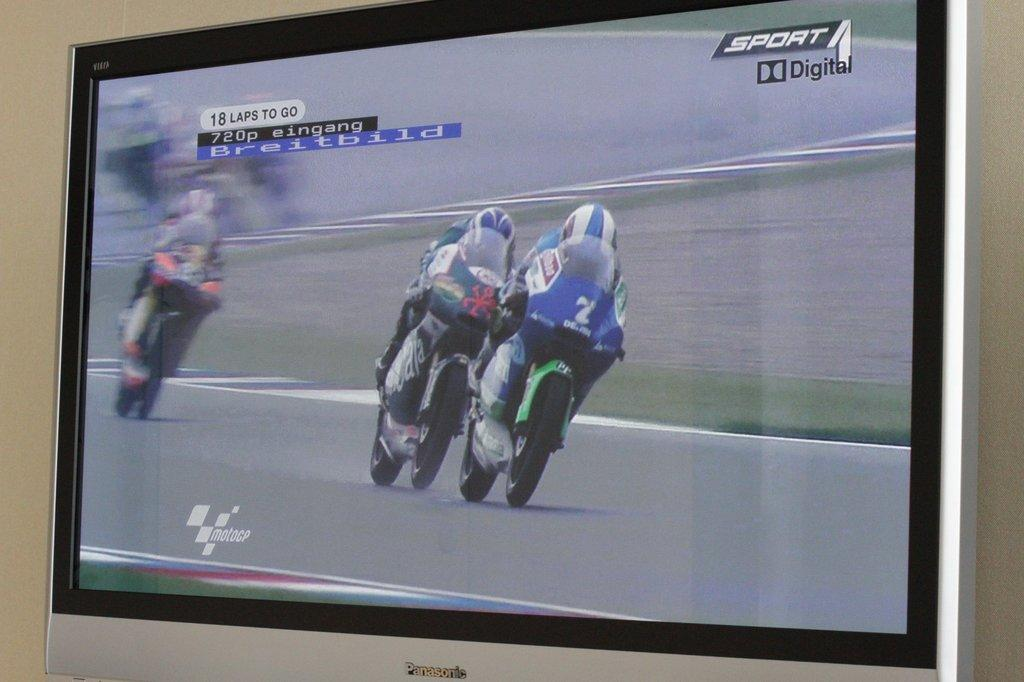<image>
Write a terse but informative summary of the picture. A Panasonic television screen is airing a motorcycle race. 